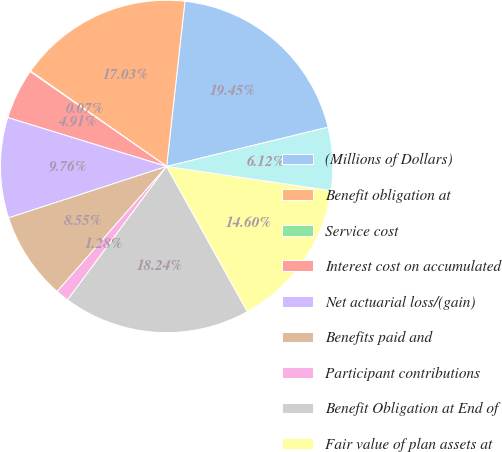Convert chart to OTSL. <chart><loc_0><loc_0><loc_500><loc_500><pie_chart><fcel>(Millions of Dollars)<fcel>Benefit obligation at<fcel>Service cost<fcel>Interest cost on accumulated<fcel>Net actuarial loss/(gain)<fcel>Benefits paid and<fcel>Participant contributions<fcel>Benefit Obligation at End of<fcel>Fair value of plan assets at<fcel>Actual return on plan assets<nl><fcel>19.45%<fcel>17.03%<fcel>0.07%<fcel>4.91%<fcel>9.76%<fcel>8.55%<fcel>1.28%<fcel>18.24%<fcel>14.6%<fcel>6.12%<nl></chart> 